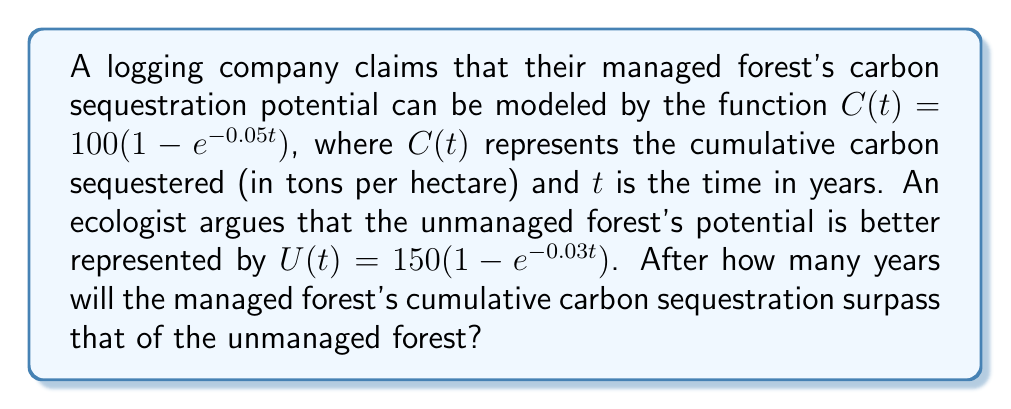Teach me how to tackle this problem. To solve this problem, we need to find the point where the two functions intersect. This occurs when:

$$100(1 - e^{-0.05t}) = 150(1 - e^{-0.03t})$$

Let's solve this equation step by step:

1) Expand the brackets:
   $$100 - 100e^{-0.05t} = 150 - 150e^{-0.03t}$$

2) Subtract 100 from both sides:
   $$-100e^{-0.05t} = 50 - 150e^{-0.03t}$$

3) Add $150e^{-0.03t}$ to both sides:
   $$150e^{-0.03t} - 100e^{-0.05t} = 50$$

4) This equation cannot be solved algebraically. We need to use numerical methods or graphing to find the solution.

5) Using a graphing calculator or computer software, we can find that the intersection occurs at approximately $t = 69.3$ years.

6) Since we're asked for the number of years after which the managed forest's sequestration surpasses the unmanaged forest's, we need to round up to the next whole year.

Therefore, after 70 years, the managed forest's cumulative carbon sequestration will surpass that of the unmanaged forest.
Answer: 70 years 